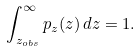<formula> <loc_0><loc_0><loc_500><loc_500>\int _ { z _ { o b s } } ^ { \infty } p _ { z } ( z ) \, d z = 1 .</formula> 